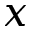Convert formula to latex. <formula><loc_0><loc_0><loc_500><loc_500>x</formula> 